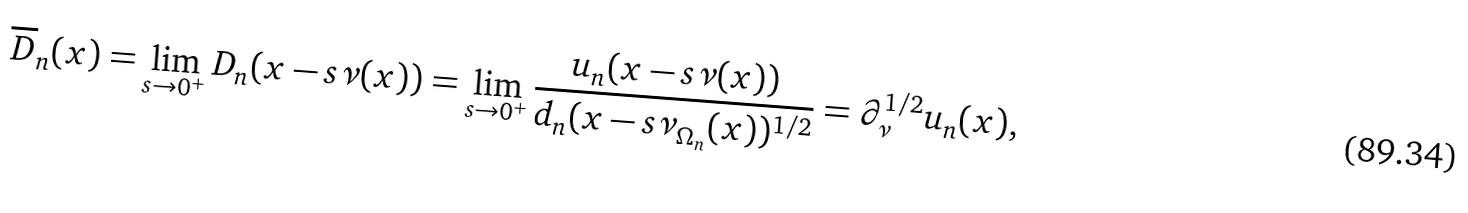<formula> <loc_0><loc_0><loc_500><loc_500>\overline { D } _ { n } ( x ) = \lim _ { s \to 0 ^ { + } } D _ { n } ( x - s \nu ( x ) ) = \lim _ { s \to 0 ^ { + } } \frac { u _ { n } ( x - s \nu ( x ) ) } { d _ { n } ( x - s \nu _ { \Omega _ { n } } ( x ) ) ^ { 1 / 2 } } = \partial _ { \nu } ^ { 1 / 2 } u _ { n } ( x ) ,</formula> 